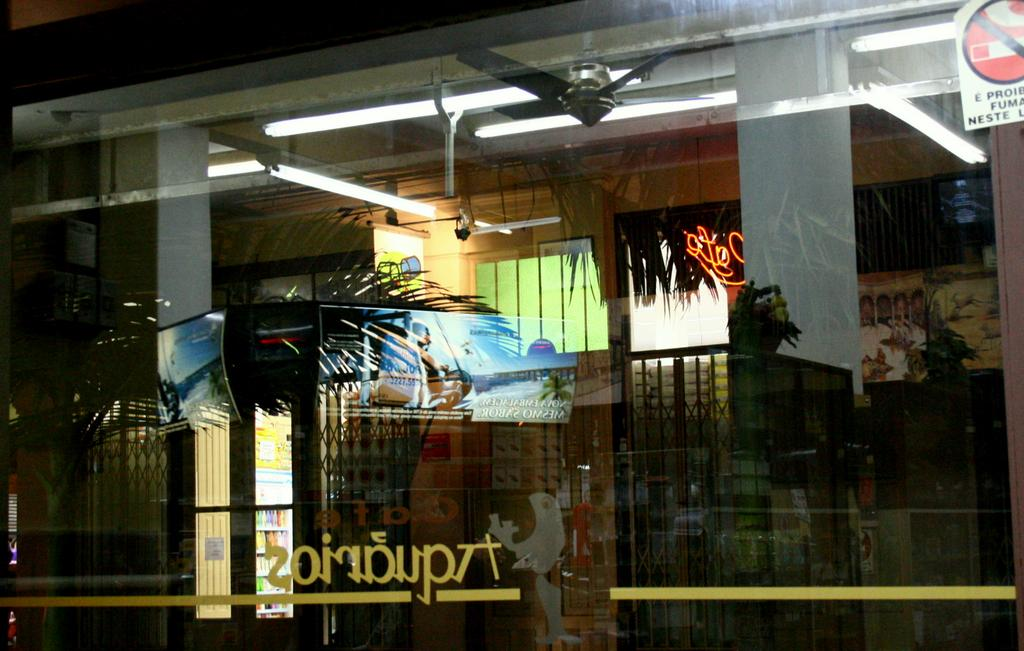What is the main feature in the center of the image? There is a glass window in the center of the image. What can be seen in the reflection of the window? The reflection of trees, a metal gate, a fan, a light, and stalls are visible in the window. Can you describe the type of window? It is a glass window. What type of creature can be seen sitting on the chin of the person in the image? There is no person or creature present in the image; it features a glass window with various reflections. 